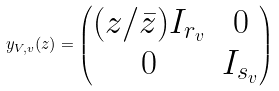<formula> <loc_0><loc_0><loc_500><loc_500>y _ { V , v } ( z ) = \begin{pmatrix} ( z / \bar { z } ) I _ { r _ { v } } & 0 \\ 0 & I _ { s _ { v } } \end{pmatrix}</formula> 